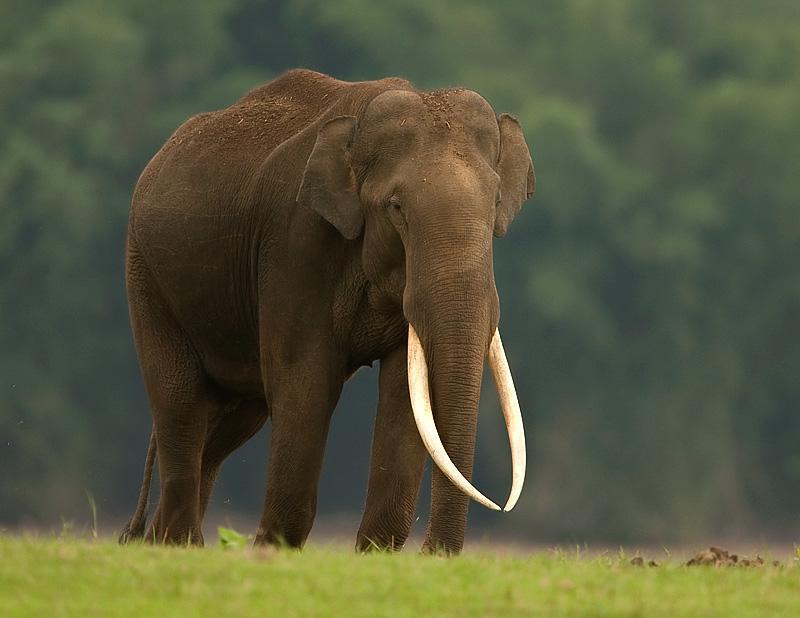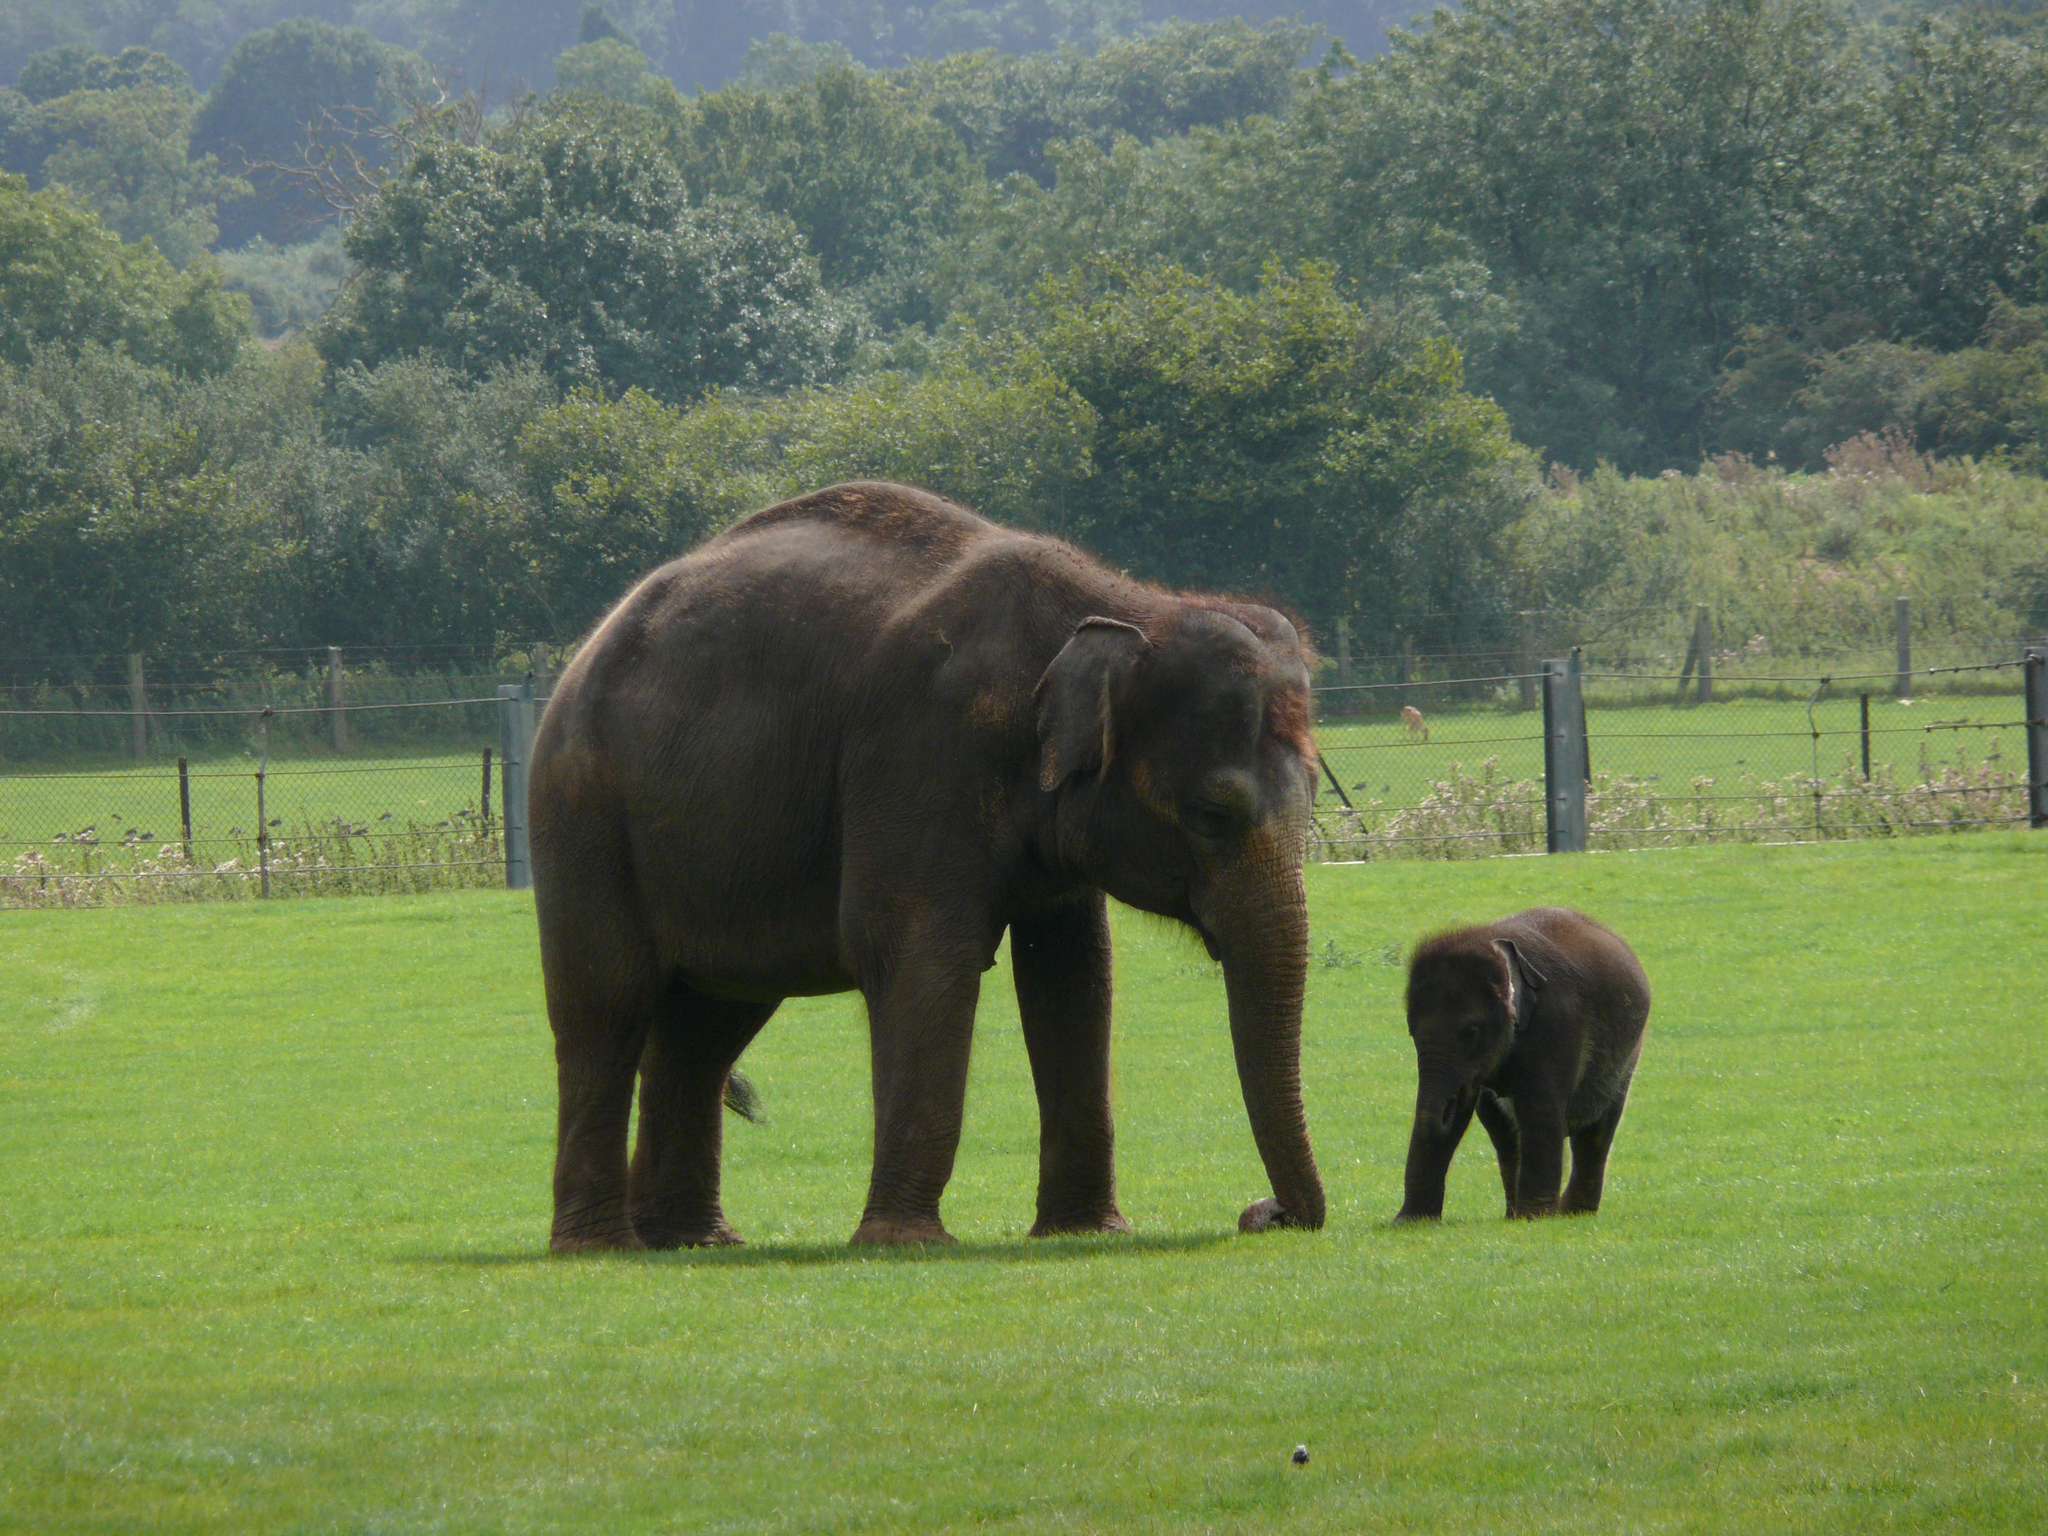The first image is the image on the left, the second image is the image on the right. Considering the images on both sides, is "At baby elephant is near at least 1 other grown elephant." valid? Answer yes or no. Yes. 